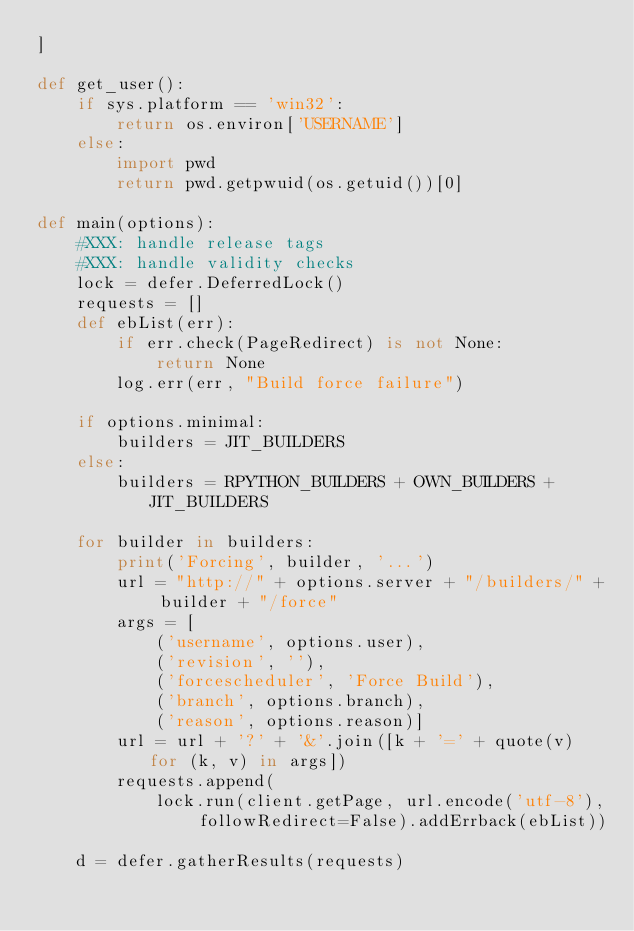<code> <loc_0><loc_0><loc_500><loc_500><_Python_>]

def get_user():
    if sys.platform == 'win32':
        return os.environ['USERNAME']
    else:
        import pwd
        return pwd.getpwuid(os.getuid())[0]

def main(options):
    #XXX: handle release tags
    #XXX: handle validity checks
    lock = defer.DeferredLock()
    requests = []
    def ebList(err):
        if err.check(PageRedirect) is not None:
            return None
        log.err(err, "Build force failure")

    if options.minimal:
        builders = JIT_BUILDERS
    else:
        builders = RPYTHON_BUILDERS + OWN_BUILDERS + JIT_BUILDERS

    for builder in builders:
        print('Forcing', builder, '...')
        url = "http://" + options.server + "/builders/" + builder + "/force"
        args = [
            ('username', options.user),
            ('revision', ''),
            ('forcescheduler', 'Force Build'),
            ('branch', options.branch),
            ('reason', options.reason)]
        url = url + '?' + '&'.join([k + '=' + quote(v) for (k, v) in args])
        requests.append(
            lock.run(client.getPage, url.encode('utf-8'), followRedirect=False).addErrback(ebList))

    d = defer.gatherResults(requests)</code> 